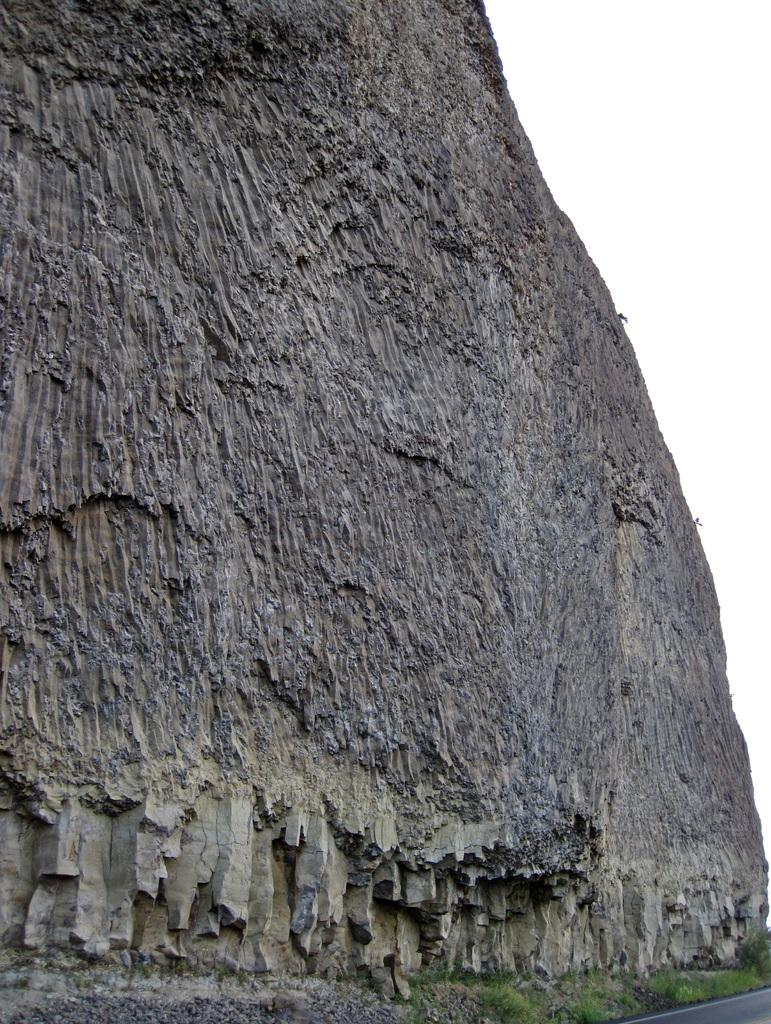What is the main object in the image? There is a rock in the image. What is located at the bottom of the image? There is a road at the bottom of the image. What can be seen in the background of the image? The sky is visible in the background of the image. Can you see any boats in the harbor in the image? There is no harbor present in the image, so it is not possible to see any boats. 